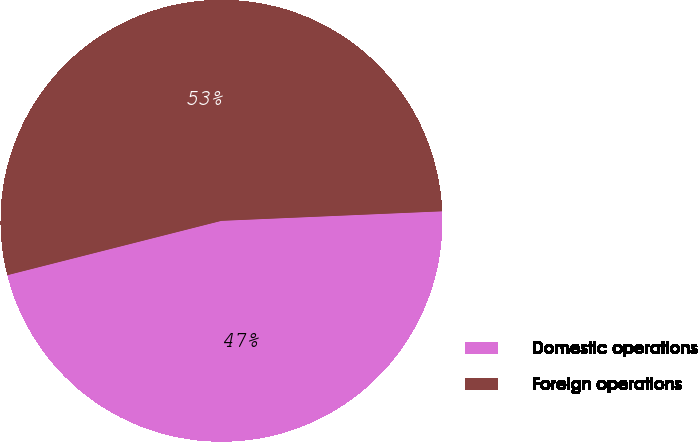<chart> <loc_0><loc_0><loc_500><loc_500><pie_chart><fcel>Domestic operations<fcel>Foreign operations<nl><fcel>46.73%<fcel>53.27%<nl></chart> 